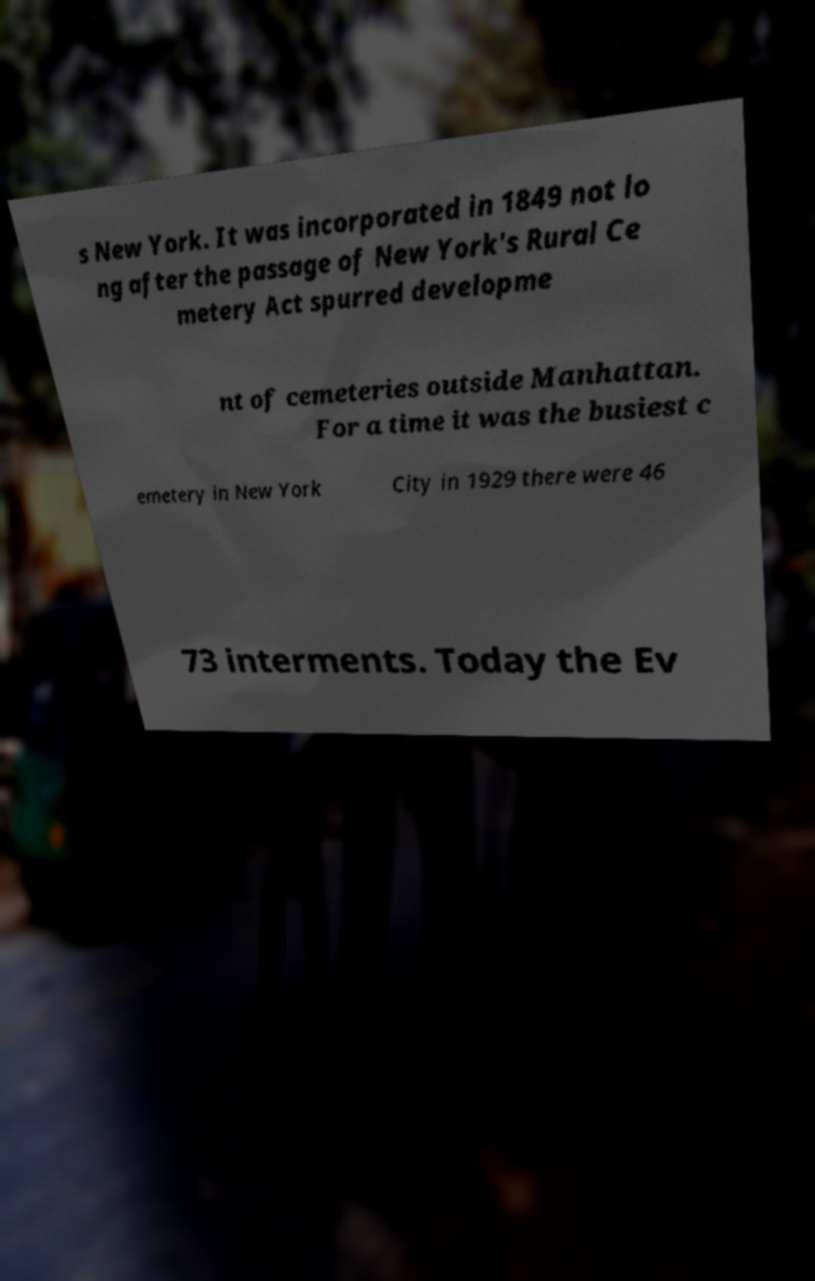There's text embedded in this image that I need extracted. Can you transcribe it verbatim? s New York. It was incorporated in 1849 not lo ng after the passage of New York's Rural Ce metery Act spurred developme nt of cemeteries outside Manhattan. For a time it was the busiest c emetery in New York City in 1929 there were 46 73 interments. Today the Ev 